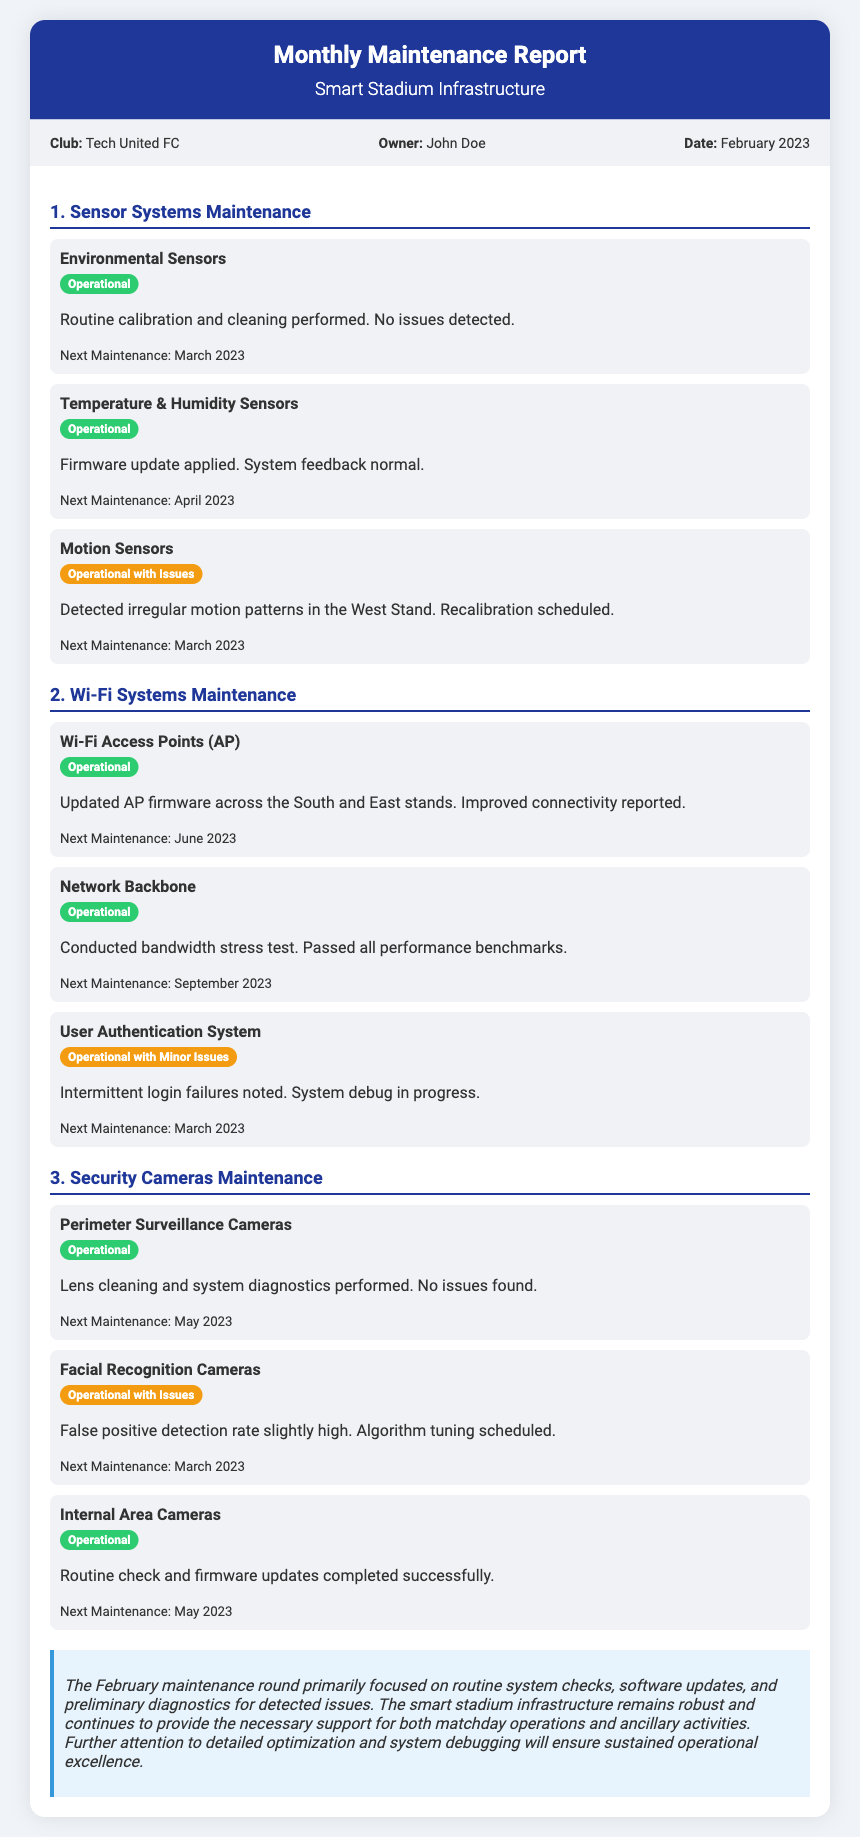What is the name of the club? The document states that the club's name is Tech United FC.
Answer: Tech United FC Who is the owner of the club? According to the document, the owner of the club is John Doe.
Answer: John Doe What is the status of the Environmental Sensors? The status of the Environmental Sensors is operational, as mentioned in the document.
Answer: Operational How many systems reported issues in the Sensor Systems Maintenance section? In the Sensor Systems Maintenance section, only one system reported issues, the Motion Sensors.
Answer: One What is the next maintenance date for Motion Sensors? The document states that the next maintenance for Motion Sensors is scheduled for March 2023.
Answer: March 2023 What was the outcome of the bandwidth stress test conducted on the Network Backbone? The document indicates that the Network Backbone passed all performance benchmarks during the bandwidth stress test.
Answer: Passed How many components are listed under Security Cameras Maintenance? The Security Cameras Maintenance section lists three components: Perimeter Surveillance Cameras, Facial Recognition Cameras, and Internal Area Cameras.
Answer: Three What is stated about the User Authentication System issues? The document states that there are intermittent login failures noted for the User Authentication System.
Answer: Intermittent login failures What proactive measure is mentioned for Facial Recognition Cameras? The document mentions that algorithm tuning is scheduled for the Facial Recognition Cameras due to a high false positive detection rate.
Answer: Algorithm tuning 